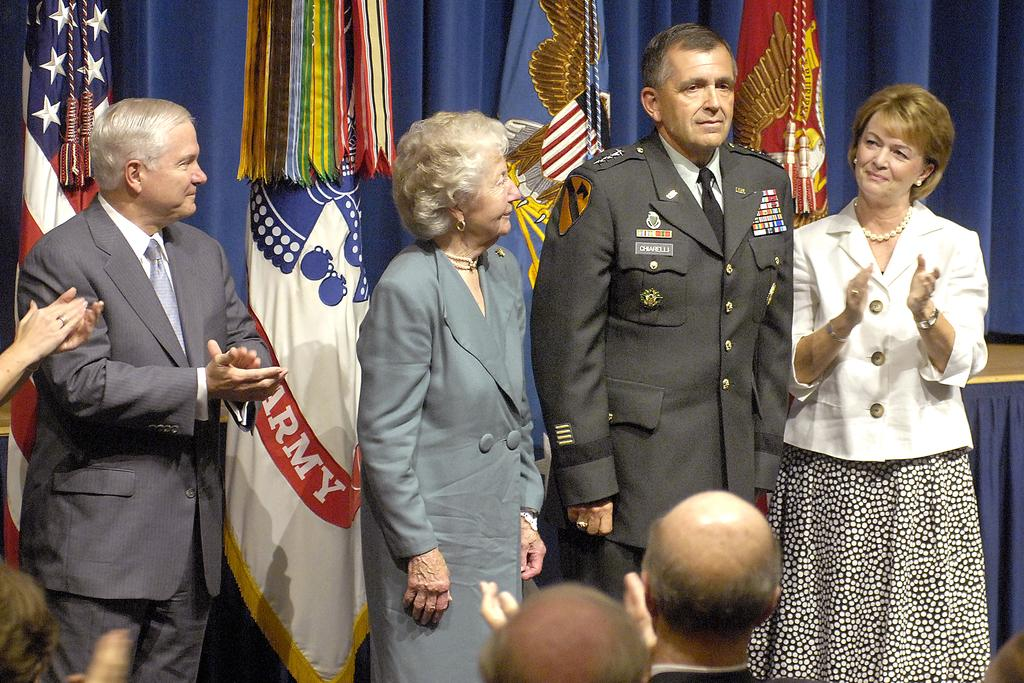Who are the main subjects in the image? There is a man and a lady standing in the center of the image. What are the people in the background doing? The people in the background are clapping their hands. What can be seen in the image that represents a symbol or country? There are flags visible in the image. What type of property is being sold in the image? There is no property being sold in the image; it features a man, a lady, and people clapping in the background. Can you tell me how many airports are visible in the image? There are no airports present in the image. 